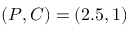Convert formula to latex. <formula><loc_0><loc_0><loc_500><loc_500>( P , C ) = ( 2 . 5 , 1 )</formula> 